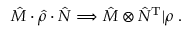Convert formula to latex. <formula><loc_0><loc_0><loc_500><loc_500>\hat { M } \cdot \hat { \rho } \cdot \hat { N } \Longrightarrow \hat { M } \otimes \hat { N } ^ { T } | \rho \ r r a n g l e .</formula> 